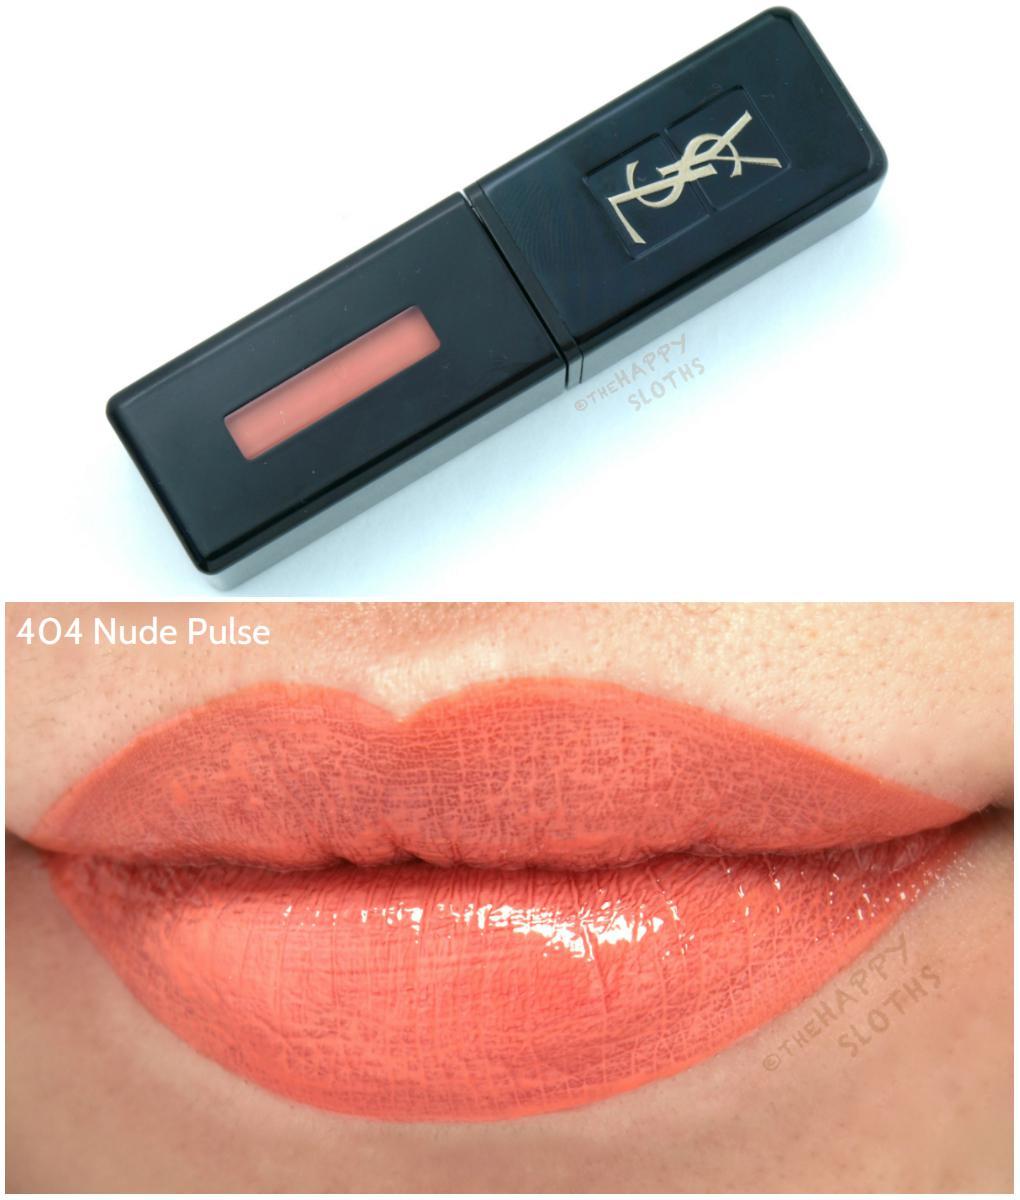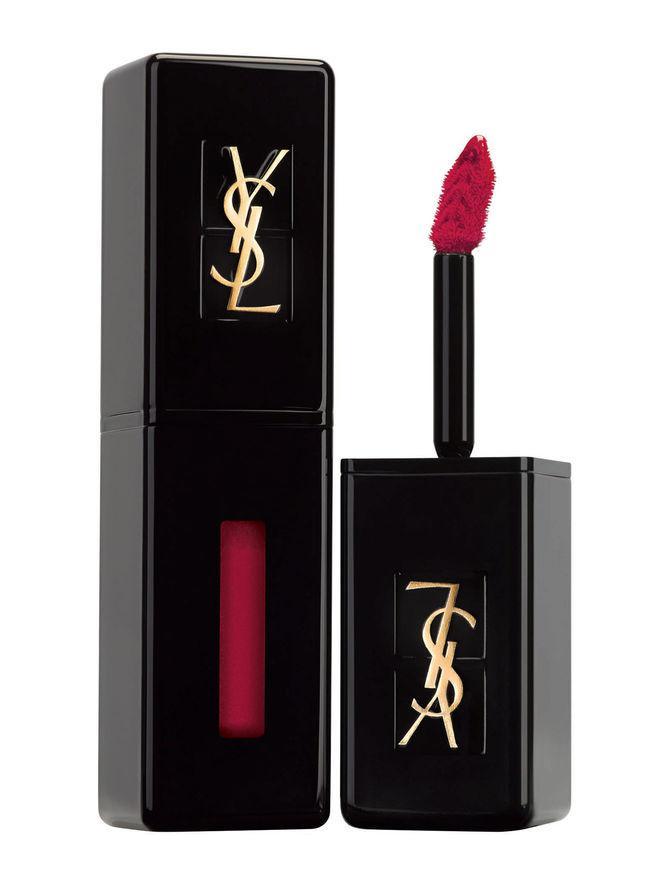The first image is the image on the left, the second image is the image on the right. For the images displayed, is the sentence "A single set of lips is shown under a tube of lipstick in one of the images." factually correct? Answer yes or no. Yes. The first image is the image on the left, the second image is the image on the right. Given the left and right images, does the statement "In one image, a woman's lips are visible with lip makeup" hold true? Answer yes or no. Yes. 